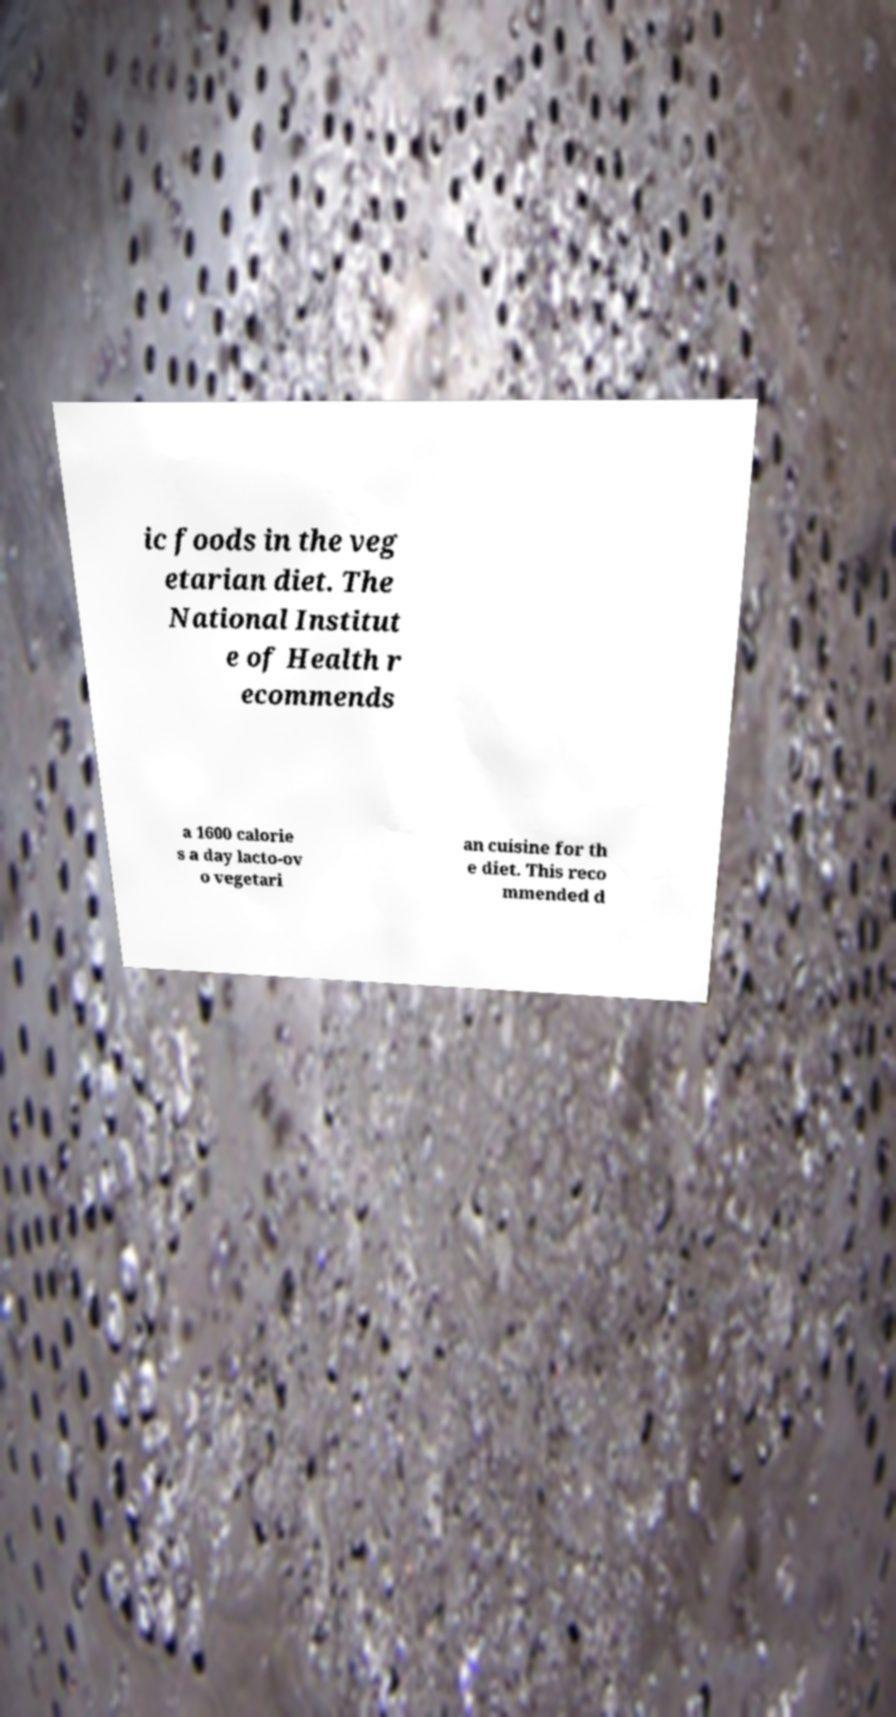I need the written content from this picture converted into text. Can you do that? ic foods in the veg etarian diet. The National Institut e of Health r ecommends a 1600 calorie s a day lacto-ov o vegetari an cuisine for th e diet. This reco mmended d 